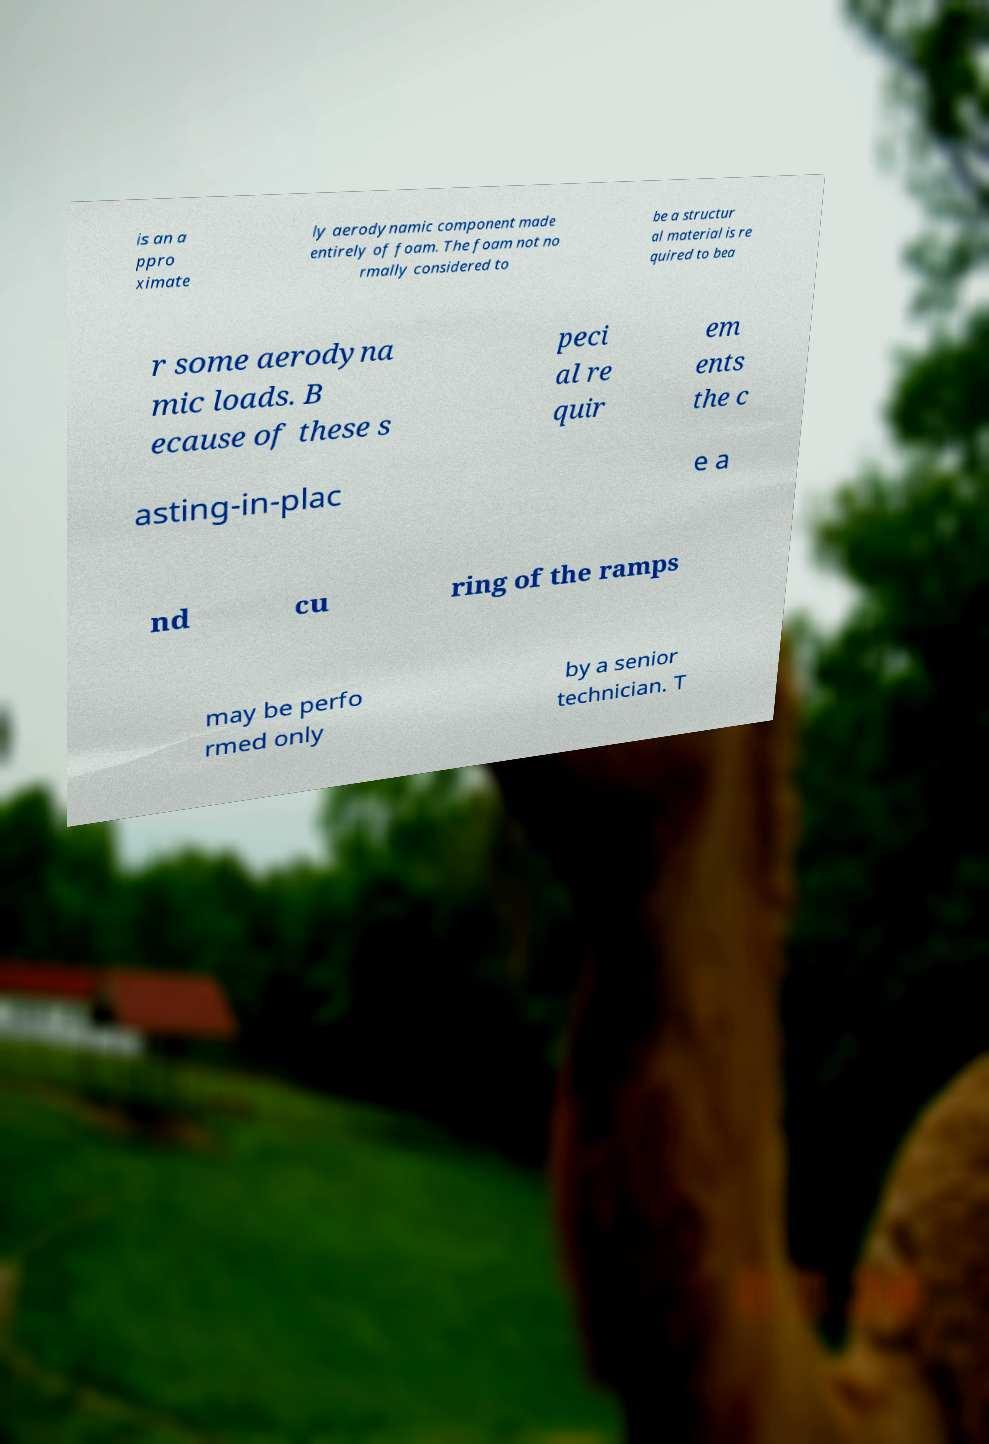Could you extract and type out the text from this image? is an a ppro ximate ly aerodynamic component made entirely of foam. The foam not no rmally considered to be a structur al material is re quired to bea r some aerodyna mic loads. B ecause of these s peci al re quir em ents the c asting-in-plac e a nd cu ring of the ramps may be perfo rmed only by a senior technician. T 